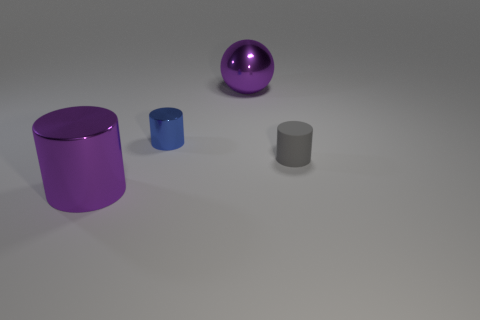What material is the cylinder that is right of the sphere to the right of the blue object made of?
Keep it short and to the point. Rubber. Are there any shiny cylinders that are in front of the big purple thing behind the shiny thing in front of the gray thing?
Ensure brevity in your answer.  Yes. Is there a gray cylinder?
Offer a terse response. Yes. Are there more big purple metal things on the right side of the tiny blue shiny cylinder than gray rubber cylinders that are on the left side of the gray rubber object?
Ensure brevity in your answer.  Yes. What size is the ball that is the same material as the large cylinder?
Provide a succinct answer. Large. There is a purple thing on the left side of the metal cylinder behind the big purple cylinder to the left of the gray matte cylinder; what size is it?
Give a very brief answer. Large. There is a metal cylinder that is behind the large purple metal cylinder; what is its color?
Keep it short and to the point. Blue. Are there more big balls to the left of the tiny gray object than small yellow rubber balls?
Provide a short and direct response. Yes. Does the big purple thing that is behind the gray cylinder have the same shape as the small blue shiny object?
Ensure brevity in your answer.  No. What number of blue things are either small blocks or small metal cylinders?
Your answer should be compact. 1. 